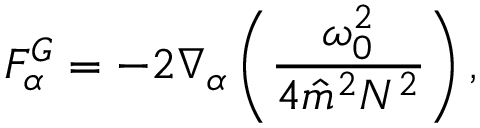<formula> <loc_0><loc_0><loc_500><loc_500>F _ { \alpha } ^ { G } = - 2 \nabla _ { \alpha } \left ( \frac { \omega _ { 0 } ^ { 2 } } { 4 \hat { m } ^ { 2 } N ^ { 2 } } \right ) ,</formula> 